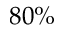<formula> <loc_0><loc_0><loc_500><loc_500>8 0 \%</formula> 